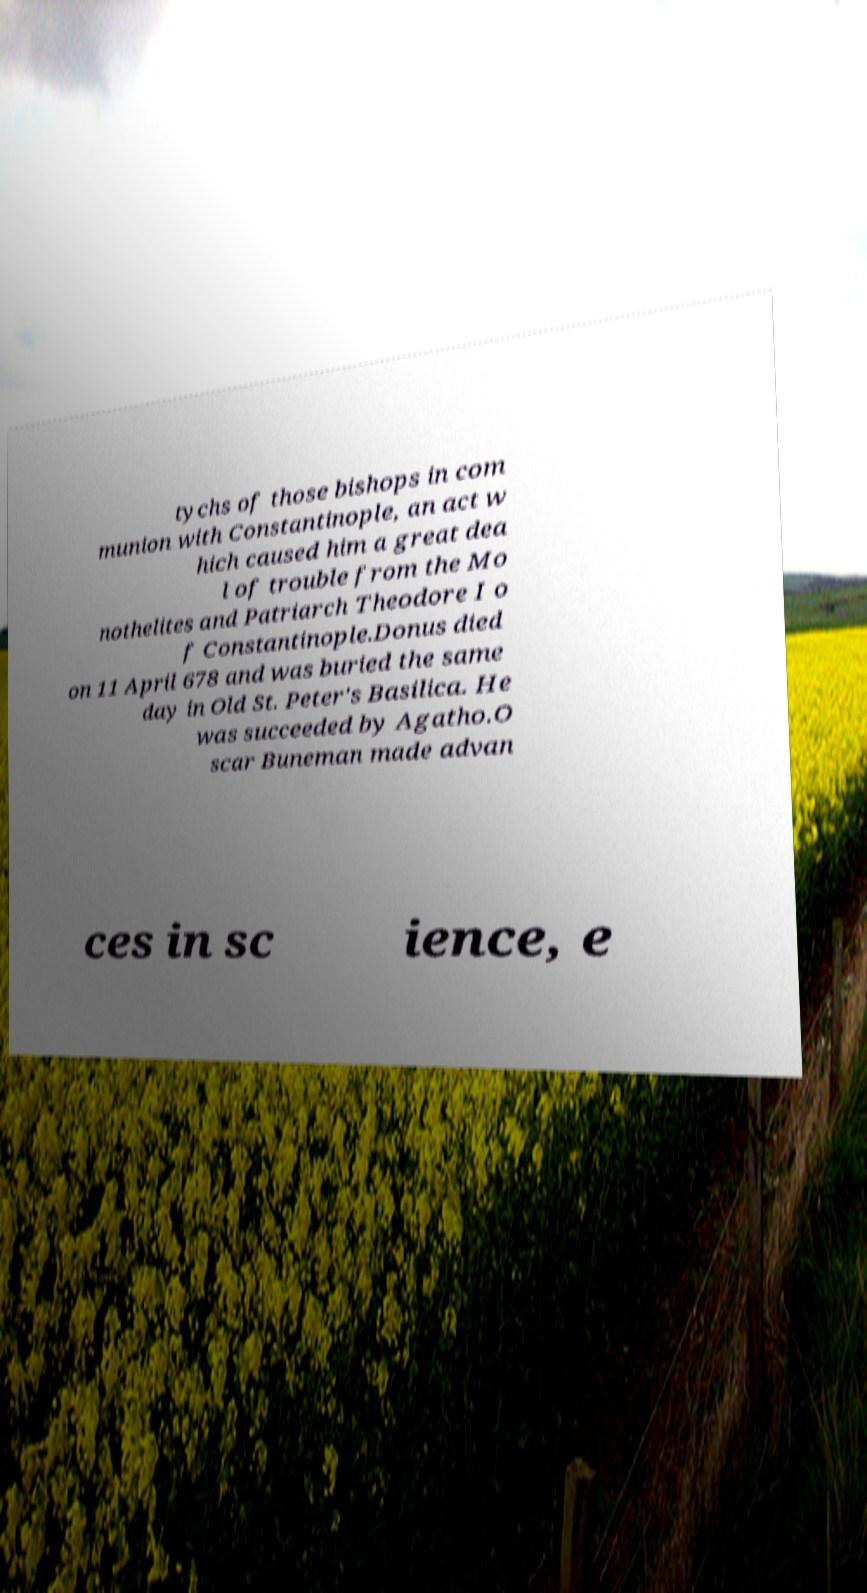Can you read and provide the text displayed in the image?This photo seems to have some interesting text. Can you extract and type it out for me? tychs of those bishops in com munion with Constantinople, an act w hich caused him a great dea l of trouble from the Mo nothelites and Patriarch Theodore I o f Constantinople.Donus died on 11 April 678 and was buried the same day in Old St. Peter's Basilica. He was succeeded by Agatho.O scar Buneman made advan ces in sc ience, e 